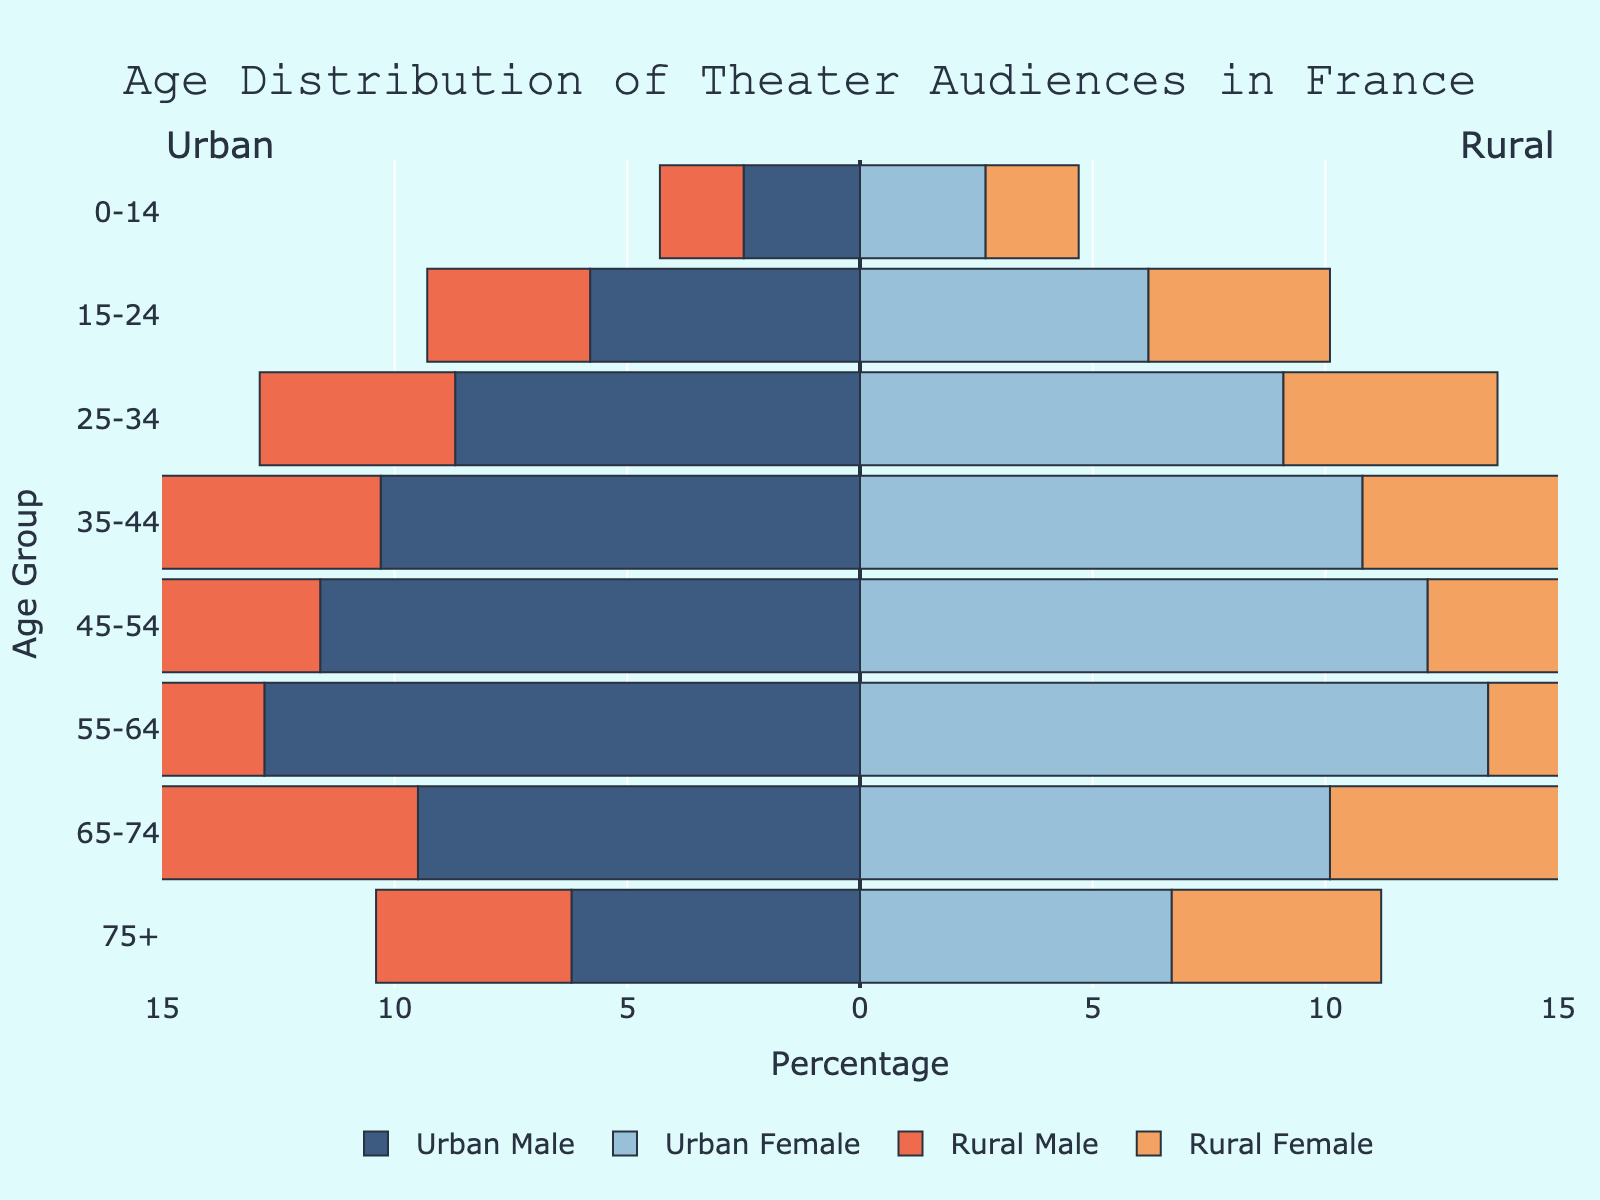What is the title of the figure? The title is located at the top of the figure and provides a summary of what the figure represents.
Answer: Age Distribution of Theater Audiences in France Which gender in urban areas has the highest percentage in the age group 35-44? Check the bars corresponding to the age group 35-44 for urban areas and compare the lengths between the male and female sections.
Answer: Urban Female How does the percentage of rural males in the age group 55-64 compare to the percentage of rural females in the same age group? Compare the length of the bar for rural males to the bar for rural females in the age group 55-64.
Answer: Rural females have a higher percentage What is the percentage difference between urban males and rural males in the age group 25-34? Subtract the percentage of rural males from urban males in the age group 25-34.
Answer: 4.5% Which age group in urban areas has the smallest gender gap? Examine the differences in the lengths of the bars for males and females in each age group and find the smallest difference.
Answer: 0-14 What is the total percentage of urban theater audience in the age group 45-54? Add the percentages of urban males and urban females in the age group 45-54.
Answer: 23.8% What is the median age group for rural female theater audiences? Determine the age group corresponding to the middle value of the data when rural female percentages are ranked in order.
Answer: 45-54 Which gender and area combination has the lowest percentage in the age group 75+? Check the lengths of all bars in the age group 75+ to find the lowest percentage.
Answer: Rural male In which age group is the difference between urban and rural female theater audiences the greatest? Calculate the difference for each age group and identify which group has the largest difference.
Answer: 25-34 How does the percentage of the urban male theater audience in the age group 15-24 compare to the percentage of the rural male audience in the same age group? Compare the lengths of the bars for urban males and rural males in the age group 15-24.
Answer: Urban males have a higher percentage 